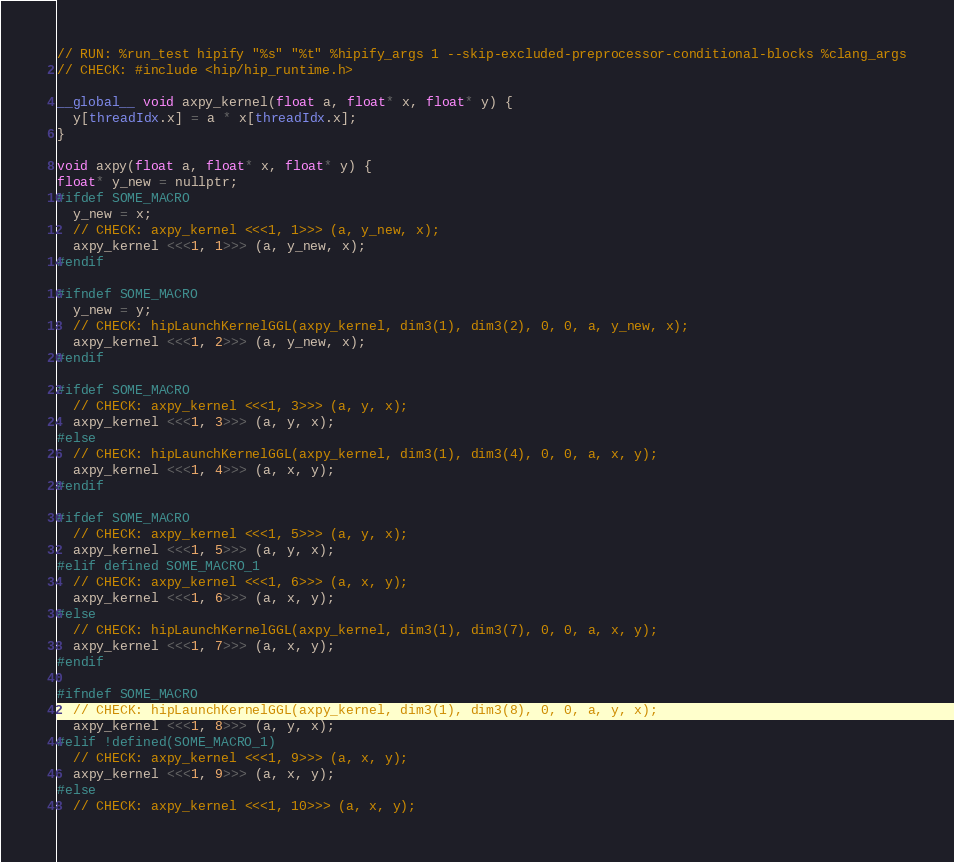<code> <loc_0><loc_0><loc_500><loc_500><_Cuda_>// RUN: %run_test hipify "%s" "%t" %hipify_args 1 --skip-excluded-preprocessor-conditional-blocks %clang_args
// CHECK: #include <hip/hip_runtime.h>

__global__ void axpy_kernel(float a, float* x, float* y) {
  y[threadIdx.x] = a * x[threadIdx.x];
}

void axpy(float a, float* x, float* y) {
float* y_new = nullptr;
#ifdef SOME_MACRO
  y_new = x;
  // CHECK: axpy_kernel <<<1, 1>>> (a, y_new, x);
  axpy_kernel <<<1, 1>>> (a, y_new, x);
#endif

#ifndef SOME_MACRO
  y_new = y;
  // CHECK: hipLaunchKernelGGL(axpy_kernel, dim3(1), dim3(2), 0, 0, a, y_new, x);
  axpy_kernel <<<1, 2>>> (a, y_new, x);
#endif

#ifdef SOME_MACRO
  // CHECK: axpy_kernel <<<1, 3>>> (a, y, x);
  axpy_kernel <<<1, 3>>> (a, y, x);
#else
  // CHECK: hipLaunchKernelGGL(axpy_kernel, dim3(1), dim3(4), 0, 0, a, x, y);
  axpy_kernel <<<1, 4>>> (a, x, y);
#endif

#ifdef SOME_MACRO
  // CHECK: axpy_kernel <<<1, 5>>> (a, y, x);
  axpy_kernel <<<1, 5>>> (a, y, x);
#elif defined SOME_MACRO_1
  // CHECK: axpy_kernel <<<1, 6>>> (a, x, y);
  axpy_kernel <<<1, 6>>> (a, x, y);
#else
  // CHECK: hipLaunchKernelGGL(axpy_kernel, dim3(1), dim3(7), 0, 0, a, x, y);
  axpy_kernel <<<1, 7>>> (a, x, y);
#endif

#ifndef SOME_MACRO
  // CHECK: hipLaunchKernelGGL(axpy_kernel, dim3(1), dim3(8), 0, 0, a, y, x);
  axpy_kernel <<<1, 8>>> (a, y, x);
#elif !defined(SOME_MACRO_1)
  // CHECK: axpy_kernel <<<1, 9>>> (a, x, y);
  axpy_kernel <<<1, 9>>> (a, x, y);
#else
  // CHECK: axpy_kernel <<<1, 10>>> (a, x, y);</code> 